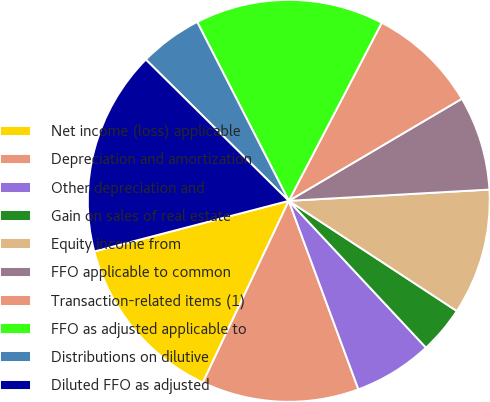<chart> <loc_0><loc_0><loc_500><loc_500><pie_chart><fcel>Net income (loss) applicable<fcel>Depreciation and amortization<fcel>Other depreciation and<fcel>Gain on sales of real estate<fcel>Equity income from<fcel>FFO applicable to common<fcel>Transaction-related items (1)<fcel>FFO as adjusted applicable to<fcel>Distributions on dilutive<fcel>Diluted FFO as adjusted<nl><fcel>13.92%<fcel>12.66%<fcel>6.33%<fcel>3.8%<fcel>10.13%<fcel>7.59%<fcel>8.86%<fcel>15.19%<fcel>5.06%<fcel>16.46%<nl></chart> 